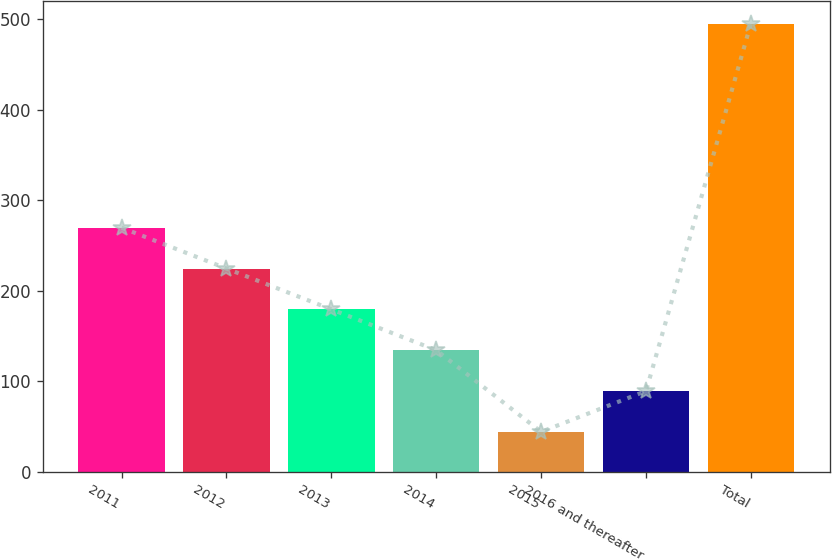<chart> <loc_0><loc_0><loc_500><loc_500><bar_chart><fcel>2011<fcel>2012<fcel>2013<fcel>2014<fcel>2015<fcel>2016 and thereafter<fcel>Total<nl><fcel>269.5<fcel>224.4<fcel>179.3<fcel>134.2<fcel>44<fcel>89.1<fcel>495<nl></chart> 